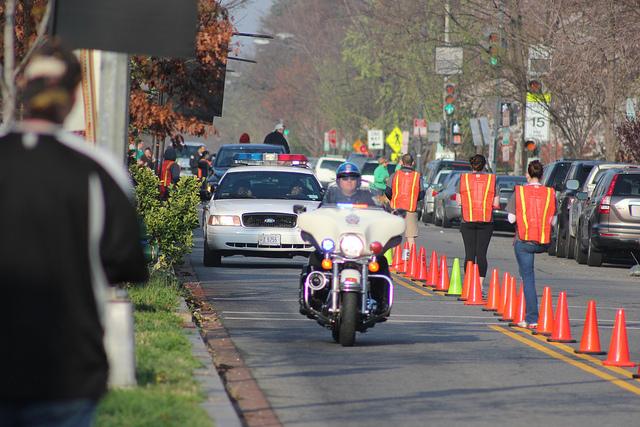What color are the stripes on the vests?
Concise answer only. Yellow. What is the occupation of the man on the motorcycle?
Concise answer only. Police. Is the car racing the motorcycle?
Give a very brief answer. No. How many motorcycles are in the crosswalk?
Write a very short answer. 1. 